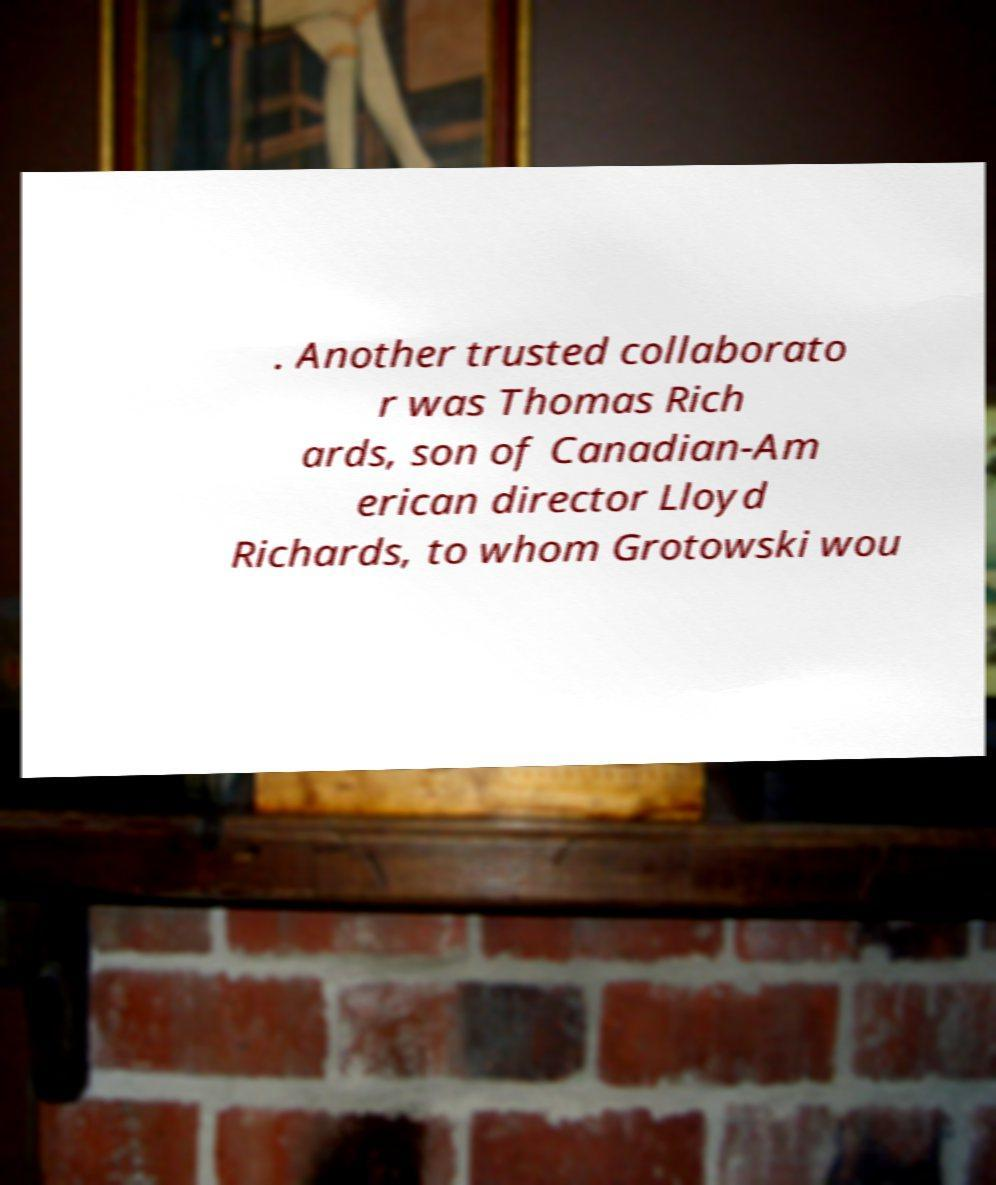Please identify and transcribe the text found in this image. . Another trusted collaborato r was Thomas Rich ards, son of Canadian-Am erican director Lloyd Richards, to whom Grotowski wou 